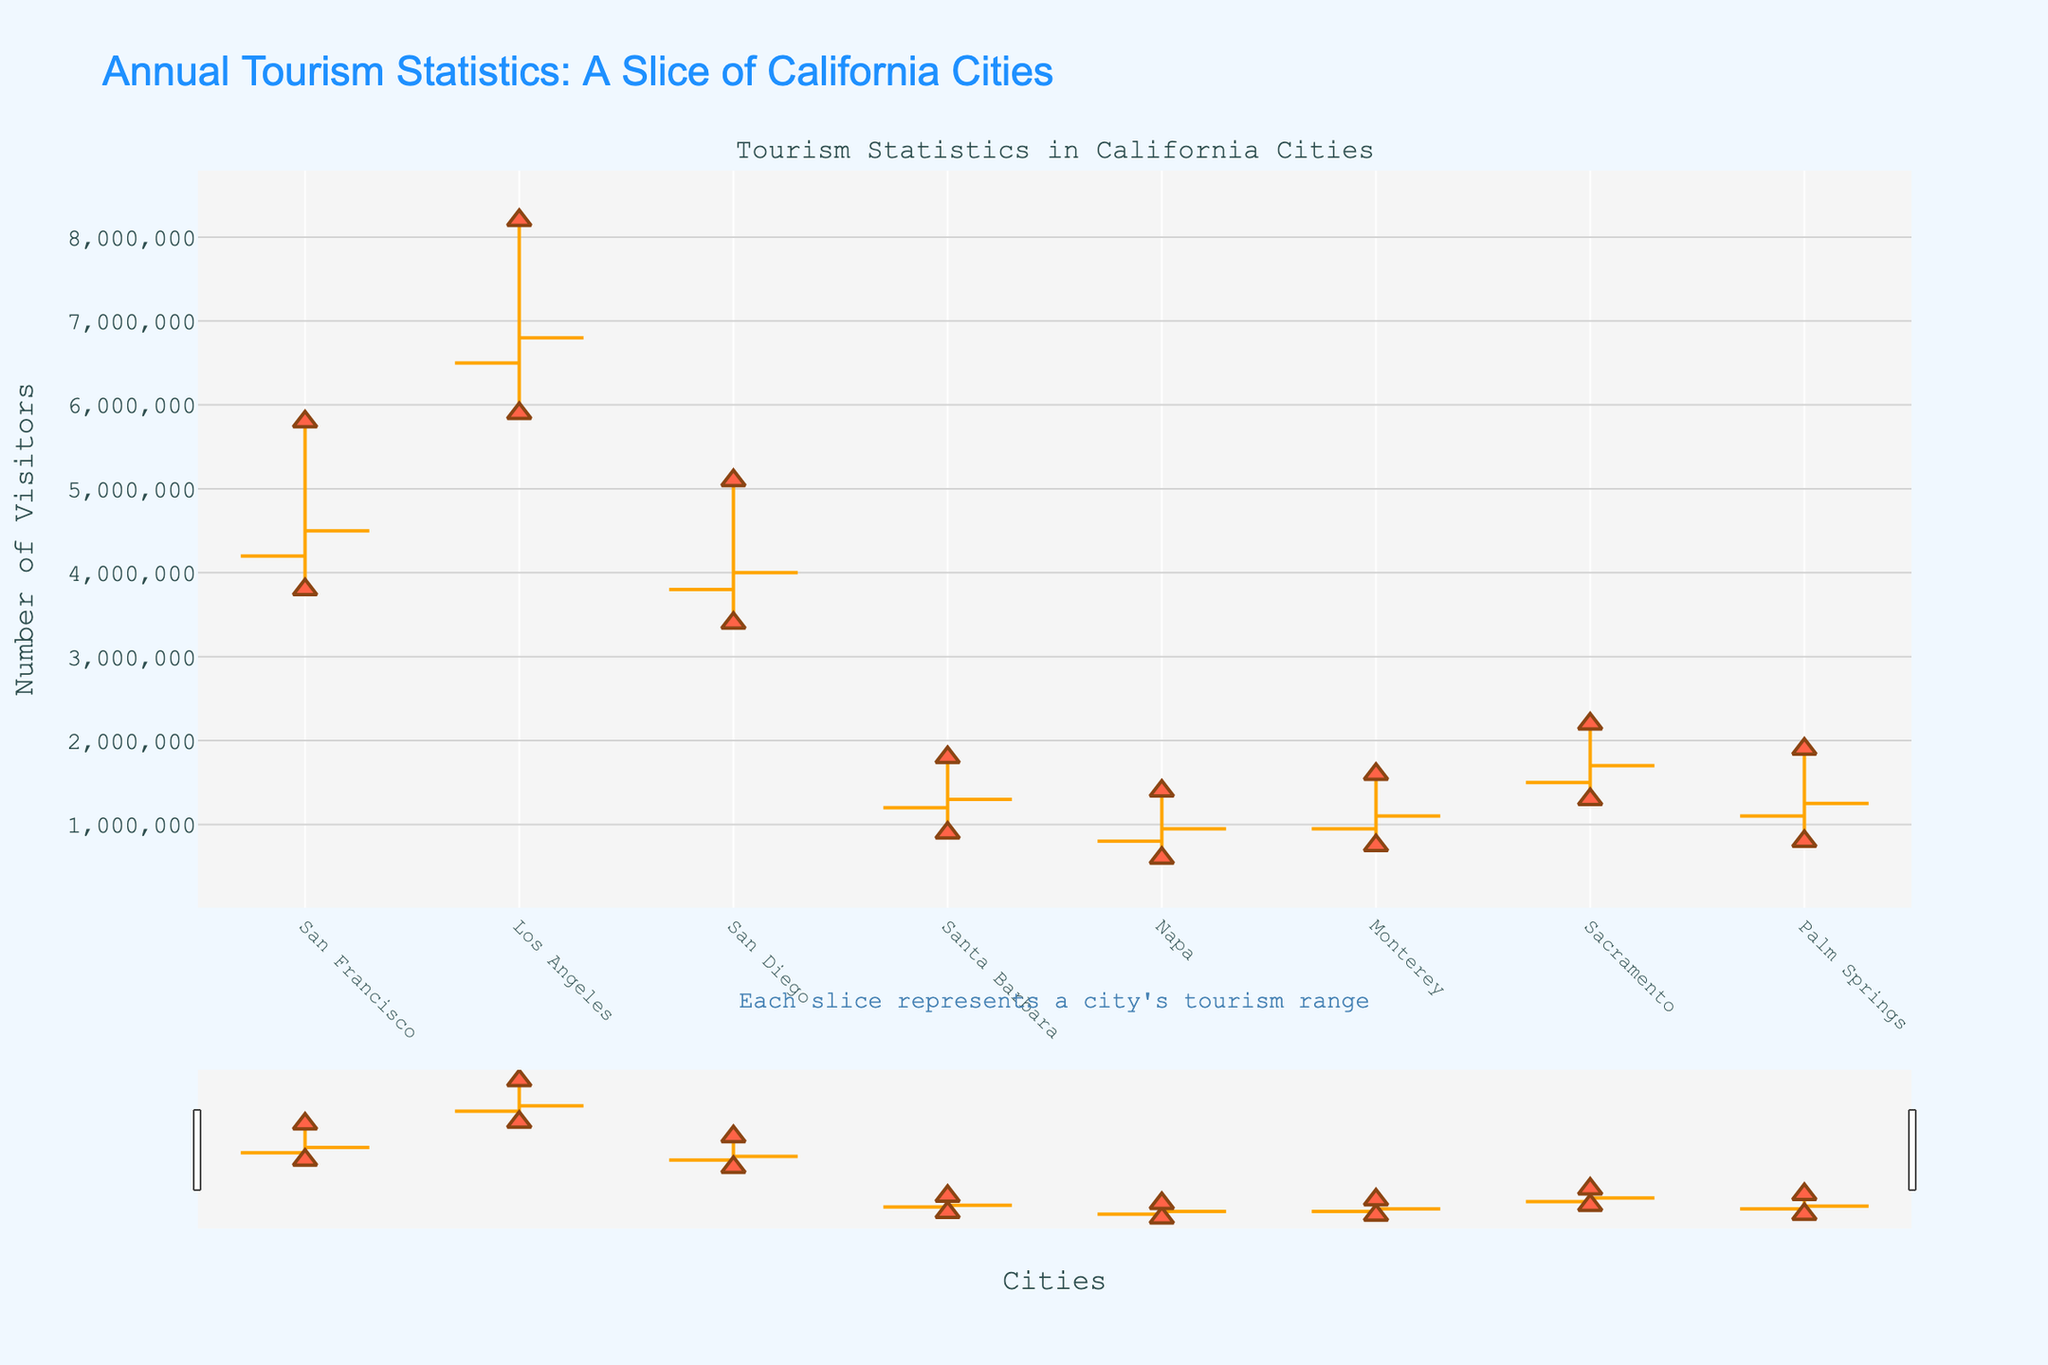what is the title of the chart? The title is usually displayed prominently at the top of the chart, summarizing the main idea or data being represented. The title of this figure is "Annual Tourism Statistics: A Slice of California Cities"
Answer: Annual Tourism Statistics: A Slice of California Cities how many cities are represented in the chart? To determine the number of cities, count the distinct labels along the x-axis. The chart uses cities like San Francisco, Los Angeles, etc., as labels.
Answer: 8 which city had the highest peak number of visitors? To identify this, look for the highest value among the max visitor points for all cities in the chart. Los Angeles is evident from the highest peak point.
Answer: Los Angeles between San Francisco and Palm Springs, which city had a higher range in tourism numbers? Calculate the range (highest - lowest) for both cities. For San Francisco: 5,800,000 - 3,800,000 = 2,000,000; for Palm Springs: 1,900,000 - 800,000 = 1,100,000. Therefore, San Francisco had a higher range.
Answer: San Francisco what is the average closing number of visitors across all cities? Add the closing numbers for all cities and divide by the number of cities. The calculation is (4,500,000 + 6,800,000 + 4,000,000 + 1,300,000 + 950,000 + 1,100,000 + 1,700,000 + 1,250,000) / 8.
Answer: 2,950,000 which city recorded the lowest number of visitors at any point during the year? Scan the low points of each city's OHLC bar to find the minimum value. Napa recorded the lowest at 600,000 visitors.
Answer: Napa how does the number of highest visitors in San Diego compare to the number of lowest visitors in Los Angeles? Find and compare the values: San Diego's highest is 5,100,000 and Los Angeles's lowest is 5,900,000. San Diego's highest is less than Los Angeles's lowest.
Answer: Less which city saw a decrease in visitors from the opening to closing figures? Examine the opening and closing numbers for each city. If the closing number is lower than the opening, the city saw a decrease. For example, Napa (800,000 to 950,000 implies a decrease).
Answer: Napa was incorrectly evaluated as an increase Did San Diego see an increase or decrease in visitors by the end of the year? Compare the opening and closing numbers for San Diego. It starts at 3,800,000 and ends at 4,000,000, indicating an increase.
Answer: Increase what is the total number of peak visitors across all cities? Sum the highest points for all cities: 5,800,000 + 8,200,000 + 5,100,000 + 1,800,000 + 1,400,000 + 1,600,000 + 2,200,000 + 1,900,000.
Answer: 27,000,000 